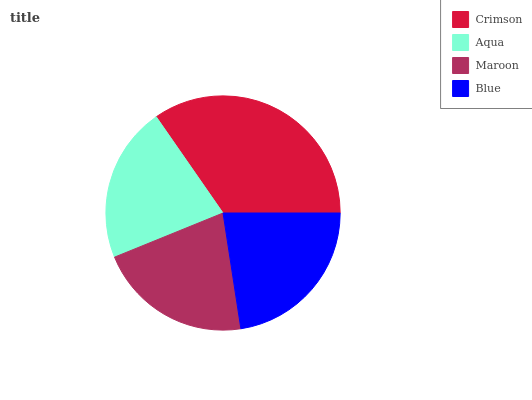Is Maroon the minimum?
Answer yes or no. Yes. Is Crimson the maximum?
Answer yes or no. Yes. Is Aqua the minimum?
Answer yes or no. No. Is Aqua the maximum?
Answer yes or no. No. Is Crimson greater than Aqua?
Answer yes or no. Yes. Is Aqua less than Crimson?
Answer yes or no. Yes. Is Aqua greater than Crimson?
Answer yes or no. No. Is Crimson less than Aqua?
Answer yes or no. No. Is Blue the high median?
Answer yes or no. Yes. Is Aqua the low median?
Answer yes or no. Yes. Is Maroon the high median?
Answer yes or no. No. Is Blue the low median?
Answer yes or no. No. 